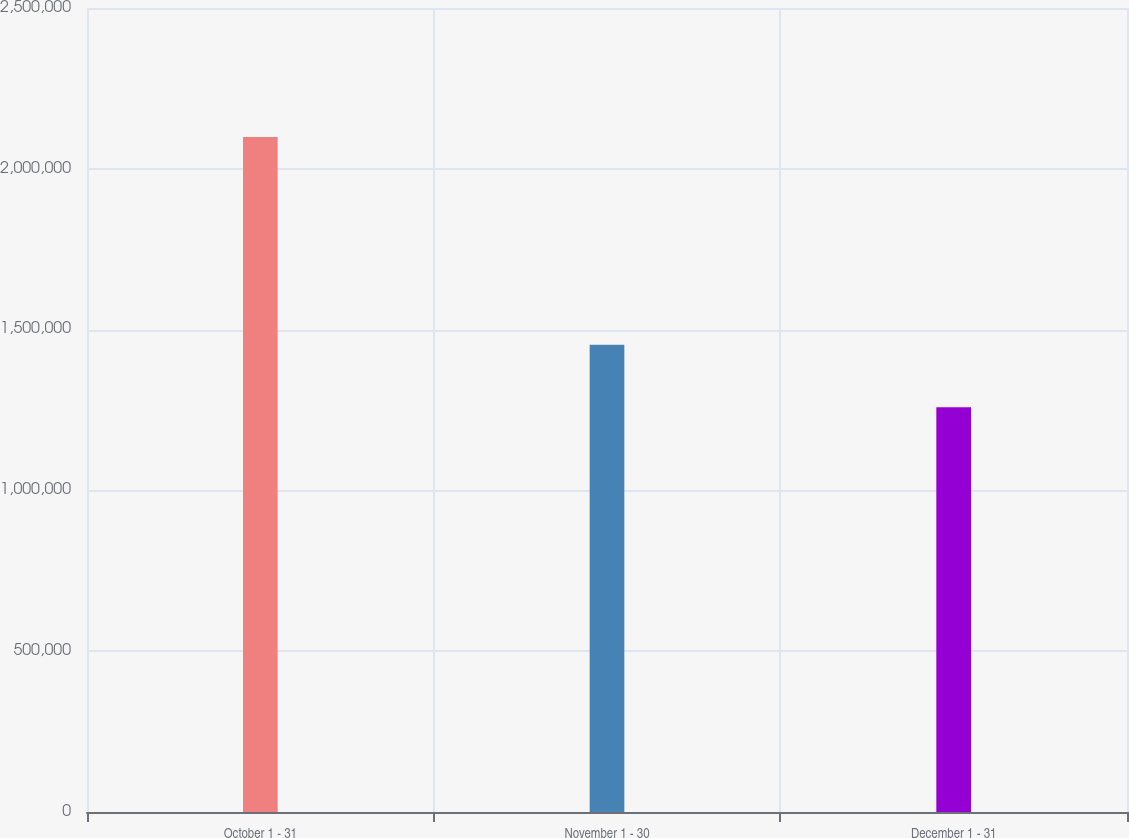Convert chart. <chart><loc_0><loc_0><loc_500><loc_500><bar_chart><fcel>October 1 - 31<fcel>November 1 - 30<fcel>December 1 - 31<nl><fcel>2.09917e+06<fcel>1.45305e+06<fcel>1.2587e+06<nl></chart> 